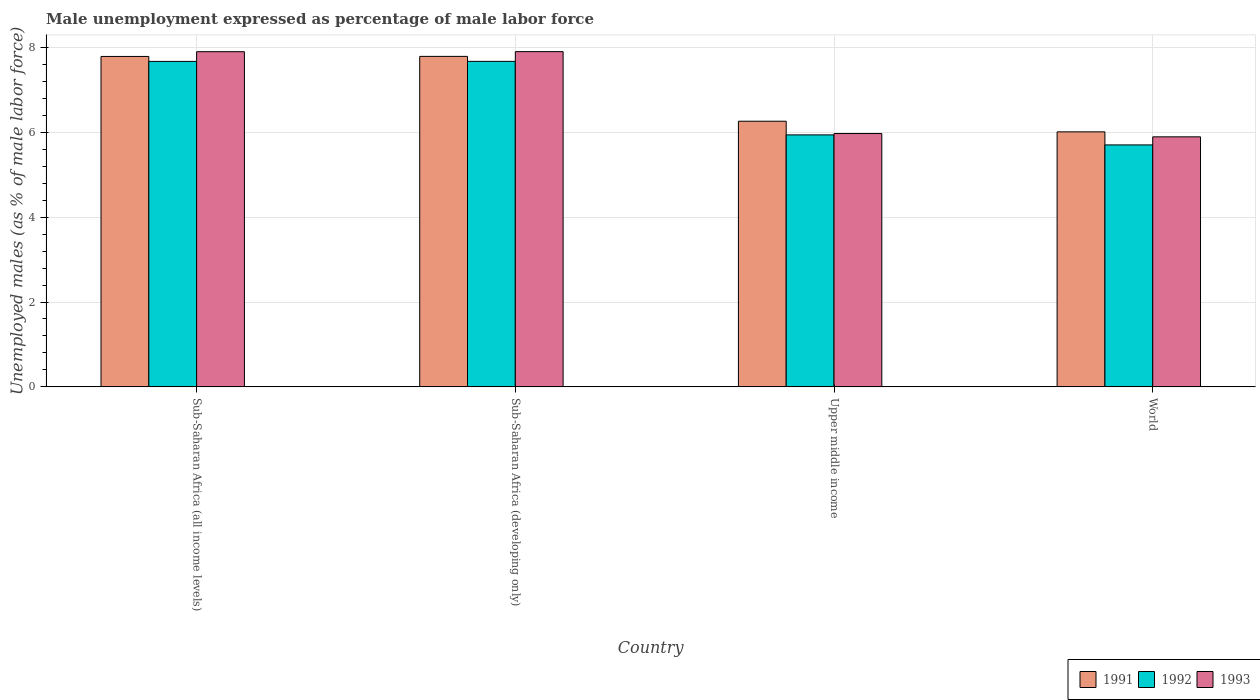How many different coloured bars are there?
Give a very brief answer. 3. Are the number of bars on each tick of the X-axis equal?
Your answer should be very brief. Yes. How many bars are there on the 3rd tick from the left?
Provide a succinct answer. 3. What is the label of the 3rd group of bars from the left?
Give a very brief answer. Upper middle income. What is the unemployment in males in in 1991 in Upper middle income?
Keep it short and to the point. 6.26. Across all countries, what is the maximum unemployment in males in in 1991?
Your response must be concise. 7.79. Across all countries, what is the minimum unemployment in males in in 1992?
Offer a very short reply. 5.7. In which country was the unemployment in males in in 1993 maximum?
Offer a terse response. Sub-Saharan Africa (developing only). What is the total unemployment in males in in 1992 in the graph?
Your response must be concise. 26.98. What is the difference between the unemployment in males in in 1993 in Sub-Saharan Africa (developing only) and that in World?
Provide a short and direct response. 2.01. What is the difference between the unemployment in males in in 1991 in Sub-Saharan Africa (all income levels) and the unemployment in males in in 1993 in Upper middle income?
Your answer should be very brief. 1.82. What is the average unemployment in males in in 1991 per country?
Provide a short and direct response. 6.96. What is the difference between the unemployment in males in of/in 1991 and unemployment in males in of/in 1993 in Sub-Saharan Africa (all income levels)?
Your answer should be very brief. -0.11. In how many countries, is the unemployment in males in in 1991 greater than 6 %?
Offer a terse response. 4. What is the ratio of the unemployment in males in in 1993 in Sub-Saharan Africa (all income levels) to that in Sub-Saharan Africa (developing only)?
Give a very brief answer. 1. Is the unemployment in males in in 1993 in Sub-Saharan Africa (all income levels) less than that in World?
Provide a succinct answer. No. What is the difference between the highest and the second highest unemployment in males in in 1993?
Make the answer very short. 1.93. What is the difference between the highest and the lowest unemployment in males in in 1991?
Ensure brevity in your answer.  1.78. What does the 1st bar from the left in Sub-Saharan Africa (developing only) represents?
Your response must be concise. 1991. What does the 3rd bar from the right in Sub-Saharan Africa (developing only) represents?
Your answer should be very brief. 1991. How many countries are there in the graph?
Keep it short and to the point. 4. Does the graph contain grids?
Provide a short and direct response. Yes. Where does the legend appear in the graph?
Your answer should be compact. Bottom right. What is the title of the graph?
Your answer should be very brief. Male unemployment expressed as percentage of male labor force. What is the label or title of the Y-axis?
Ensure brevity in your answer.  Unemployed males (as % of male labor force). What is the Unemployed males (as % of male labor force) of 1991 in Sub-Saharan Africa (all income levels)?
Offer a very short reply. 7.79. What is the Unemployed males (as % of male labor force) of 1992 in Sub-Saharan Africa (all income levels)?
Ensure brevity in your answer.  7.67. What is the Unemployed males (as % of male labor force) of 1993 in Sub-Saharan Africa (all income levels)?
Your answer should be very brief. 7.9. What is the Unemployed males (as % of male labor force) of 1991 in Sub-Saharan Africa (developing only)?
Give a very brief answer. 7.79. What is the Unemployed males (as % of male labor force) in 1992 in Sub-Saharan Africa (developing only)?
Give a very brief answer. 7.67. What is the Unemployed males (as % of male labor force) in 1993 in Sub-Saharan Africa (developing only)?
Your answer should be compact. 7.9. What is the Unemployed males (as % of male labor force) in 1991 in Upper middle income?
Offer a very short reply. 6.26. What is the Unemployed males (as % of male labor force) in 1992 in Upper middle income?
Offer a very short reply. 5.94. What is the Unemployed males (as % of male labor force) of 1993 in Upper middle income?
Ensure brevity in your answer.  5.97. What is the Unemployed males (as % of male labor force) of 1991 in World?
Provide a succinct answer. 6.01. What is the Unemployed males (as % of male labor force) of 1992 in World?
Provide a short and direct response. 5.7. What is the Unemployed males (as % of male labor force) of 1993 in World?
Provide a short and direct response. 5.89. Across all countries, what is the maximum Unemployed males (as % of male labor force) of 1991?
Offer a very short reply. 7.79. Across all countries, what is the maximum Unemployed males (as % of male labor force) in 1992?
Ensure brevity in your answer.  7.67. Across all countries, what is the maximum Unemployed males (as % of male labor force) in 1993?
Give a very brief answer. 7.9. Across all countries, what is the minimum Unemployed males (as % of male labor force) of 1991?
Your response must be concise. 6.01. Across all countries, what is the minimum Unemployed males (as % of male labor force) of 1992?
Provide a succinct answer. 5.7. Across all countries, what is the minimum Unemployed males (as % of male labor force) in 1993?
Provide a succinct answer. 5.89. What is the total Unemployed males (as % of male labor force) of 1991 in the graph?
Your answer should be very brief. 27.85. What is the total Unemployed males (as % of male labor force) in 1992 in the graph?
Provide a succinct answer. 26.98. What is the total Unemployed males (as % of male labor force) of 1993 in the graph?
Offer a terse response. 27.66. What is the difference between the Unemployed males (as % of male labor force) in 1991 in Sub-Saharan Africa (all income levels) and that in Sub-Saharan Africa (developing only)?
Your answer should be compact. -0. What is the difference between the Unemployed males (as % of male labor force) of 1992 in Sub-Saharan Africa (all income levels) and that in Sub-Saharan Africa (developing only)?
Provide a short and direct response. -0. What is the difference between the Unemployed males (as % of male labor force) in 1993 in Sub-Saharan Africa (all income levels) and that in Sub-Saharan Africa (developing only)?
Ensure brevity in your answer.  -0. What is the difference between the Unemployed males (as % of male labor force) in 1991 in Sub-Saharan Africa (all income levels) and that in Upper middle income?
Provide a succinct answer. 1.53. What is the difference between the Unemployed males (as % of male labor force) in 1992 in Sub-Saharan Africa (all income levels) and that in Upper middle income?
Offer a terse response. 1.73. What is the difference between the Unemployed males (as % of male labor force) in 1993 in Sub-Saharan Africa (all income levels) and that in Upper middle income?
Provide a succinct answer. 1.93. What is the difference between the Unemployed males (as % of male labor force) of 1991 in Sub-Saharan Africa (all income levels) and that in World?
Provide a succinct answer. 1.78. What is the difference between the Unemployed males (as % of male labor force) of 1992 in Sub-Saharan Africa (all income levels) and that in World?
Your answer should be compact. 1.97. What is the difference between the Unemployed males (as % of male labor force) in 1993 in Sub-Saharan Africa (all income levels) and that in World?
Your answer should be very brief. 2.01. What is the difference between the Unemployed males (as % of male labor force) of 1991 in Sub-Saharan Africa (developing only) and that in Upper middle income?
Make the answer very short. 1.53. What is the difference between the Unemployed males (as % of male labor force) in 1992 in Sub-Saharan Africa (developing only) and that in Upper middle income?
Keep it short and to the point. 1.73. What is the difference between the Unemployed males (as % of male labor force) in 1993 in Sub-Saharan Africa (developing only) and that in Upper middle income?
Your answer should be very brief. 1.93. What is the difference between the Unemployed males (as % of male labor force) of 1991 in Sub-Saharan Africa (developing only) and that in World?
Offer a very short reply. 1.78. What is the difference between the Unemployed males (as % of male labor force) of 1992 in Sub-Saharan Africa (developing only) and that in World?
Give a very brief answer. 1.97. What is the difference between the Unemployed males (as % of male labor force) of 1993 in Sub-Saharan Africa (developing only) and that in World?
Ensure brevity in your answer.  2.01. What is the difference between the Unemployed males (as % of male labor force) in 1991 in Upper middle income and that in World?
Make the answer very short. 0.25. What is the difference between the Unemployed males (as % of male labor force) in 1992 in Upper middle income and that in World?
Your answer should be very brief. 0.24. What is the difference between the Unemployed males (as % of male labor force) in 1993 in Upper middle income and that in World?
Your answer should be very brief. 0.08. What is the difference between the Unemployed males (as % of male labor force) of 1991 in Sub-Saharan Africa (all income levels) and the Unemployed males (as % of male labor force) of 1992 in Sub-Saharan Africa (developing only)?
Your answer should be compact. 0.12. What is the difference between the Unemployed males (as % of male labor force) of 1991 in Sub-Saharan Africa (all income levels) and the Unemployed males (as % of male labor force) of 1993 in Sub-Saharan Africa (developing only)?
Make the answer very short. -0.11. What is the difference between the Unemployed males (as % of male labor force) of 1992 in Sub-Saharan Africa (all income levels) and the Unemployed males (as % of male labor force) of 1993 in Sub-Saharan Africa (developing only)?
Your answer should be compact. -0.23. What is the difference between the Unemployed males (as % of male labor force) in 1991 in Sub-Saharan Africa (all income levels) and the Unemployed males (as % of male labor force) in 1992 in Upper middle income?
Ensure brevity in your answer.  1.85. What is the difference between the Unemployed males (as % of male labor force) in 1991 in Sub-Saharan Africa (all income levels) and the Unemployed males (as % of male labor force) in 1993 in Upper middle income?
Offer a terse response. 1.82. What is the difference between the Unemployed males (as % of male labor force) of 1992 in Sub-Saharan Africa (all income levels) and the Unemployed males (as % of male labor force) of 1993 in Upper middle income?
Offer a very short reply. 1.7. What is the difference between the Unemployed males (as % of male labor force) of 1991 in Sub-Saharan Africa (all income levels) and the Unemployed males (as % of male labor force) of 1992 in World?
Provide a succinct answer. 2.09. What is the difference between the Unemployed males (as % of male labor force) in 1991 in Sub-Saharan Africa (all income levels) and the Unemployed males (as % of male labor force) in 1993 in World?
Offer a very short reply. 1.89. What is the difference between the Unemployed males (as % of male labor force) of 1992 in Sub-Saharan Africa (all income levels) and the Unemployed males (as % of male labor force) of 1993 in World?
Offer a very short reply. 1.78. What is the difference between the Unemployed males (as % of male labor force) of 1991 in Sub-Saharan Africa (developing only) and the Unemployed males (as % of male labor force) of 1992 in Upper middle income?
Keep it short and to the point. 1.85. What is the difference between the Unemployed males (as % of male labor force) in 1991 in Sub-Saharan Africa (developing only) and the Unemployed males (as % of male labor force) in 1993 in Upper middle income?
Your answer should be very brief. 1.82. What is the difference between the Unemployed males (as % of male labor force) of 1992 in Sub-Saharan Africa (developing only) and the Unemployed males (as % of male labor force) of 1993 in Upper middle income?
Provide a short and direct response. 1.7. What is the difference between the Unemployed males (as % of male labor force) of 1991 in Sub-Saharan Africa (developing only) and the Unemployed males (as % of male labor force) of 1992 in World?
Your answer should be compact. 2.09. What is the difference between the Unemployed males (as % of male labor force) in 1991 in Sub-Saharan Africa (developing only) and the Unemployed males (as % of male labor force) in 1993 in World?
Make the answer very short. 1.9. What is the difference between the Unemployed males (as % of male labor force) of 1992 in Sub-Saharan Africa (developing only) and the Unemployed males (as % of male labor force) of 1993 in World?
Your answer should be very brief. 1.78. What is the difference between the Unemployed males (as % of male labor force) of 1991 in Upper middle income and the Unemployed males (as % of male labor force) of 1992 in World?
Give a very brief answer. 0.56. What is the difference between the Unemployed males (as % of male labor force) in 1991 in Upper middle income and the Unemployed males (as % of male labor force) in 1993 in World?
Make the answer very short. 0.37. What is the difference between the Unemployed males (as % of male labor force) of 1992 in Upper middle income and the Unemployed males (as % of male labor force) of 1993 in World?
Provide a short and direct response. 0.05. What is the average Unemployed males (as % of male labor force) in 1991 per country?
Keep it short and to the point. 6.96. What is the average Unemployed males (as % of male labor force) in 1992 per country?
Provide a short and direct response. 6.75. What is the average Unemployed males (as % of male labor force) of 1993 per country?
Offer a very short reply. 6.92. What is the difference between the Unemployed males (as % of male labor force) in 1991 and Unemployed males (as % of male labor force) in 1992 in Sub-Saharan Africa (all income levels)?
Make the answer very short. 0.12. What is the difference between the Unemployed males (as % of male labor force) in 1991 and Unemployed males (as % of male labor force) in 1993 in Sub-Saharan Africa (all income levels)?
Your answer should be compact. -0.11. What is the difference between the Unemployed males (as % of male labor force) in 1992 and Unemployed males (as % of male labor force) in 1993 in Sub-Saharan Africa (all income levels)?
Your response must be concise. -0.23. What is the difference between the Unemployed males (as % of male labor force) in 1991 and Unemployed males (as % of male labor force) in 1992 in Sub-Saharan Africa (developing only)?
Provide a short and direct response. 0.12. What is the difference between the Unemployed males (as % of male labor force) of 1991 and Unemployed males (as % of male labor force) of 1993 in Sub-Saharan Africa (developing only)?
Give a very brief answer. -0.11. What is the difference between the Unemployed males (as % of male labor force) of 1992 and Unemployed males (as % of male labor force) of 1993 in Sub-Saharan Africa (developing only)?
Your answer should be very brief. -0.23. What is the difference between the Unemployed males (as % of male labor force) in 1991 and Unemployed males (as % of male labor force) in 1992 in Upper middle income?
Give a very brief answer. 0.32. What is the difference between the Unemployed males (as % of male labor force) in 1991 and Unemployed males (as % of male labor force) in 1993 in Upper middle income?
Your response must be concise. 0.29. What is the difference between the Unemployed males (as % of male labor force) of 1992 and Unemployed males (as % of male labor force) of 1993 in Upper middle income?
Provide a succinct answer. -0.03. What is the difference between the Unemployed males (as % of male labor force) in 1991 and Unemployed males (as % of male labor force) in 1992 in World?
Provide a short and direct response. 0.31. What is the difference between the Unemployed males (as % of male labor force) in 1991 and Unemployed males (as % of male labor force) in 1993 in World?
Offer a terse response. 0.12. What is the difference between the Unemployed males (as % of male labor force) in 1992 and Unemployed males (as % of male labor force) in 1993 in World?
Give a very brief answer. -0.19. What is the ratio of the Unemployed males (as % of male labor force) in 1991 in Sub-Saharan Africa (all income levels) to that in Sub-Saharan Africa (developing only)?
Ensure brevity in your answer.  1. What is the ratio of the Unemployed males (as % of male labor force) of 1993 in Sub-Saharan Africa (all income levels) to that in Sub-Saharan Africa (developing only)?
Your response must be concise. 1. What is the ratio of the Unemployed males (as % of male labor force) in 1991 in Sub-Saharan Africa (all income levels) to that in Upper middle income?
Give a very brief answer. 1.24. What is the ratio of the Unemployed males (as % of male labor force) of 1992 in Sub-Saharan Africa (all income levels) to that in Upper middle income?
Ensure brevity in your answer.  1.29. What is the ratio of the Unemployed males (as % of male labor force) of 1993 in Sub-Saharan Africa (all income levels) to that in Upper middle income?
Ensure brevity in your answer.  1.32. What is the ratio of the Unemployed males (as % of male labor force) of 1991 in Sub-Saharan Africa (all income levels) to that in World?
Your response must be concise. 1.3. What is the ratio of the Unemployed males (as % of male labor force) in 1992 in Sub-Saharan Africa (all income levels) to that in World?
Offer a terse response. 1.35. What is the ratio of the Unemployed males (as % of male labor force) of 1993 in Sub-Saharan Africa (all income levels) to that in World?
Your answer should be compact. 1.34. What is the ratio of the Unemployed males (as % of male labor force) in 1991 in Sub-Saharan Africa (developing only) to that in Upper middle income?
Provide a short and direct response. 1.24. What is the ratio of the Unemployed males (as % of male labor force) in 1992 in Sub-Saharan Africa (developing only) to that in Upper middle income?
Provide a short and direct response. 1.29. What is the ratio of the Unemployed males (as % of male labor force) in 1993 in Sub-Saharan Africa (developing only) to that in Upper middle income?
Offer a very short reply. 1.32. What is the ratio of the Unemployed males (as % of male labor force) of 1991 in Sub-Saharan Africa (developing only) to that in World?
Your response must be concise. 1.3. What is the ratio of the Unemployed males (as % of male labor force) of 1992 in Sub-Saharan Africa (developing only) to that in World?
Your answer should be compact. 1.35. What is the ratio of the Unemployed males (as % of male labor force) in 1993 in Sub-Saharan Africa (developing only) to that in World?
Ensure brevity in your answer.  1.34. What is the ratio of the Unemployed males (as % of male labor force) in 1991 in Upper middle income to that in World?
Ensure brevity in your answer.  1.04. What is the ratio of the Unemployed males (as % of male labor force) of 1992 in Upper middle income to that in World?
Offer a very short reply. 1.04. What is the ratio of the Unemployed males (as % of male labor force) of 1993 in Upper middle income to that in World?
Your answer should be compact. 1.01. What is the difference between the highest and the second highest Unemployed males (as % of male labor force) in 1991?
Your answer should be compact. 0. What is the difference between the highest and the second highest Unemployed males (as % of male labor force) of 1992?
Offer a terse response. 0. What is the difference between the highest and the second highest Unemployed males (as % of male labor force) in 1993?
Your answer should be very brief. 0. What is the difference between the highest and the lowest Unemployed males (as % of male labor force) of 1991?
Keep it short and to the point. 1.78. What is the difference between the highest and the lowest Unemployed males (as % of male labor force) in 1992?
Ensure brevity in your answer.  1.97. What is the difference between the highest and the lowest Unemployed males (as % of male labor force) in 1993?
Ensure brevity in your answer.  2.01. 